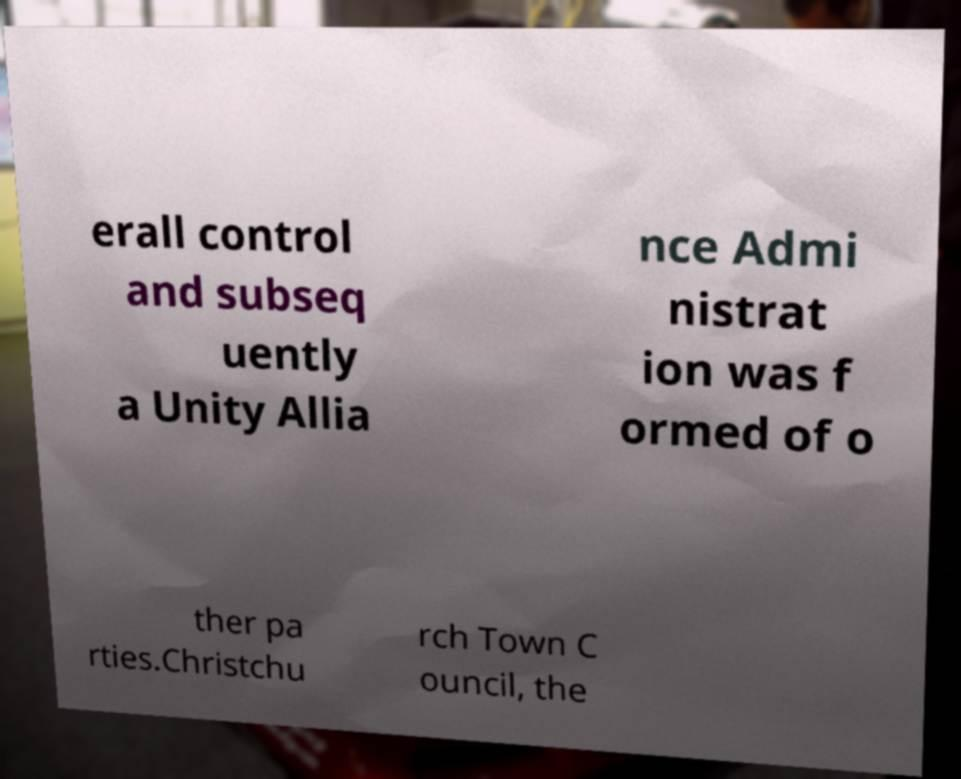Please identify and transcribe the text found in this image. erall control and subseq uently a Unity Allia nce Admi nistrat ion was f ormed of o ther pa rties.Christchu rch Town C ouncil, the 